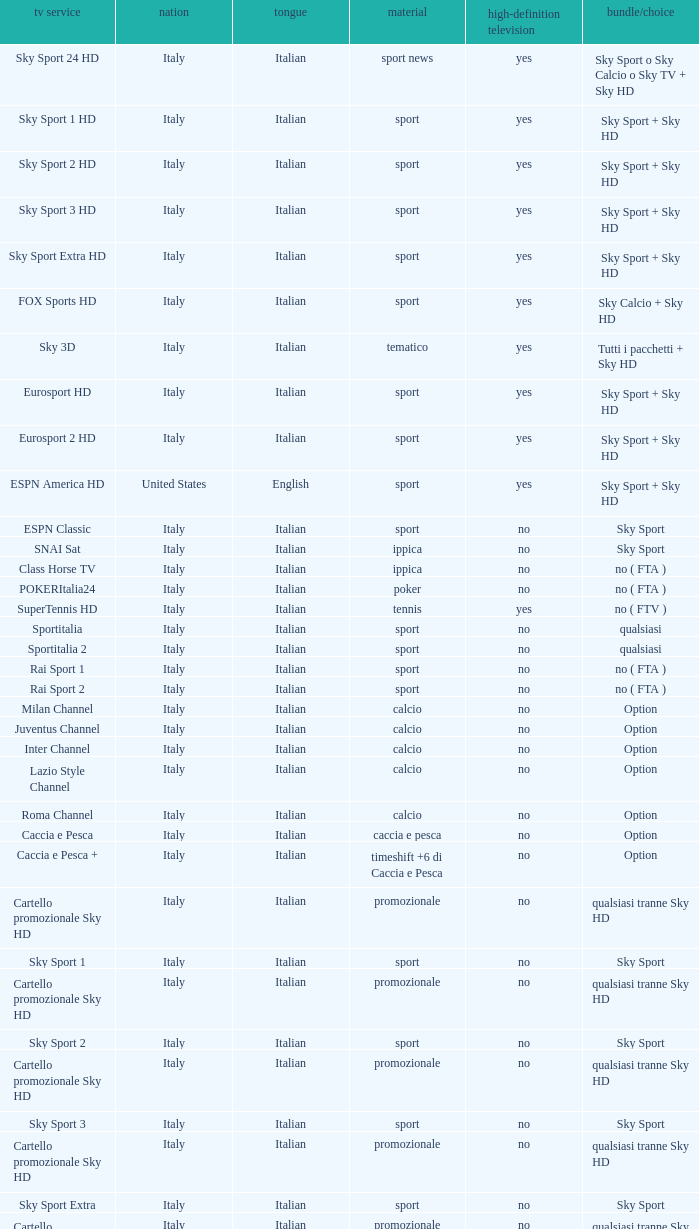What is Country, when Television Service is Eurosport 2? Italy. 